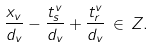Convert formula to latex. <formula><loc_0><loc_0><loc_500><loc_500>\frac { x _ { v } } { d _ { v } } - \frac { t ^ { v } _ { s } } { d _ { v } } + \frac { t ^ { v } _ { r } } { d _ { v } } \, \in \, { Z } .</formula> 